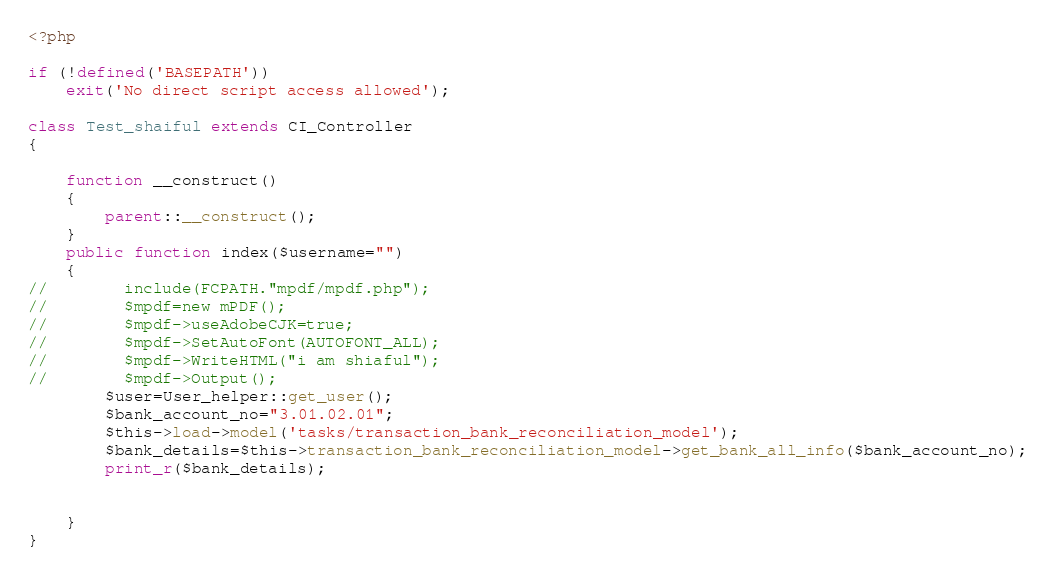<code> <loc_0><loc_0><loc_500><loc_500><_PHP_><?php

if (!defined('BASEPATH'))
    exit('No direct script access allowed');

class Test_shaiful extends CI_Controller
{

    function __construct()
    {
        parent::__construct();
    }
    public function index($username="")
    {
//        include(FCPATH."mpdf/mpdf.php");
//        $mpdf=new mPDF();
//        $mpdf->useAdobeCJK=true;
//        $mpdf->SetAutoFont(AUTOFONT_ALL);
//        $mpdf->WriteHTML("i am shiaful");
//        $mpdf->Output();
        $user=User_helper::get_user();
        $bank_account_no="3.01.02.01";
        $this->load->model('tasks/transaction_bank_reconciliation_model');
        $bank_details=$this->transaction_bank_reconciliation_model->get_bank_all_info($bank_account_no);
        print_r($bank_details);


    }
}</code> 